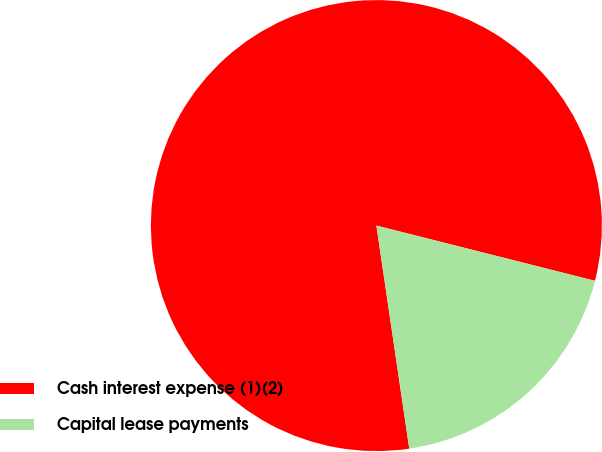Convert chart to OTSL. <chart><loc_0><loc_0><loc_500><loc_500><pie_chart><fcel>Cash interest expense (1)(2)<fcel>Capital lease payments<nl><fcel>81.27%<fcel>18.73%<nl></chart> 